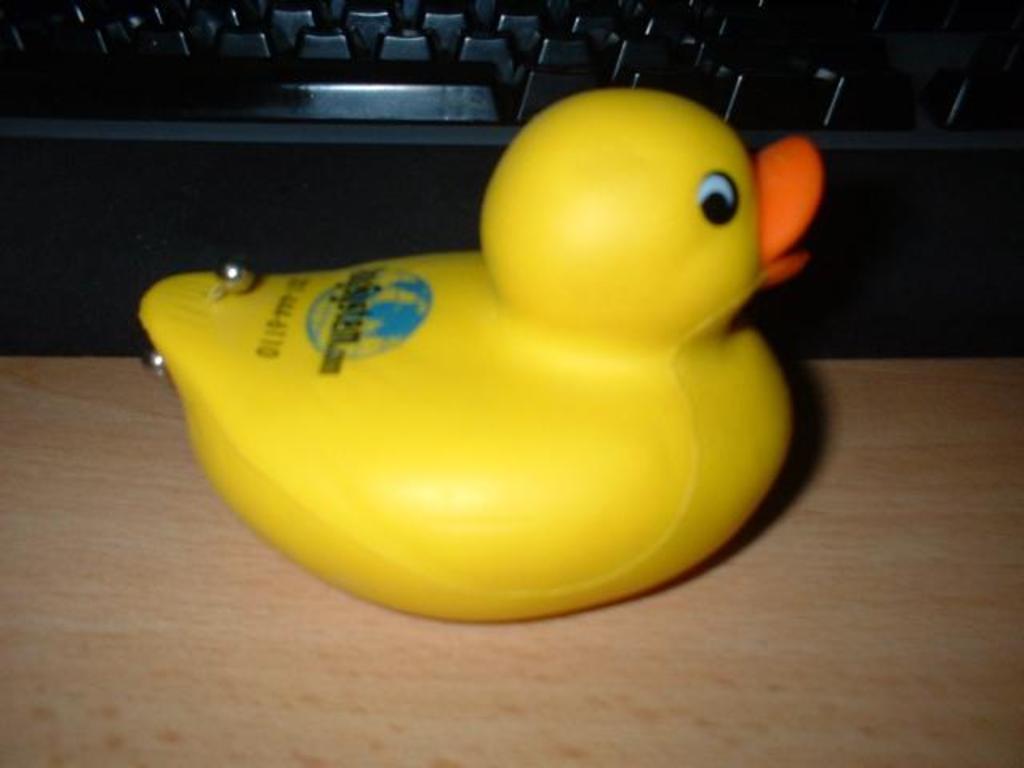Describe this image in one or two sentences. In this image we can see one yellow color duck toy on the wooden table and one black color computer keyboard on the surface. 